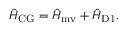<formula> <loc_0><loc_0><loc_500><loc_500>\hat { H } _ { C G } = \hat { H } _ { m v } + \hat { H } _ { D 1 } .</formula> 